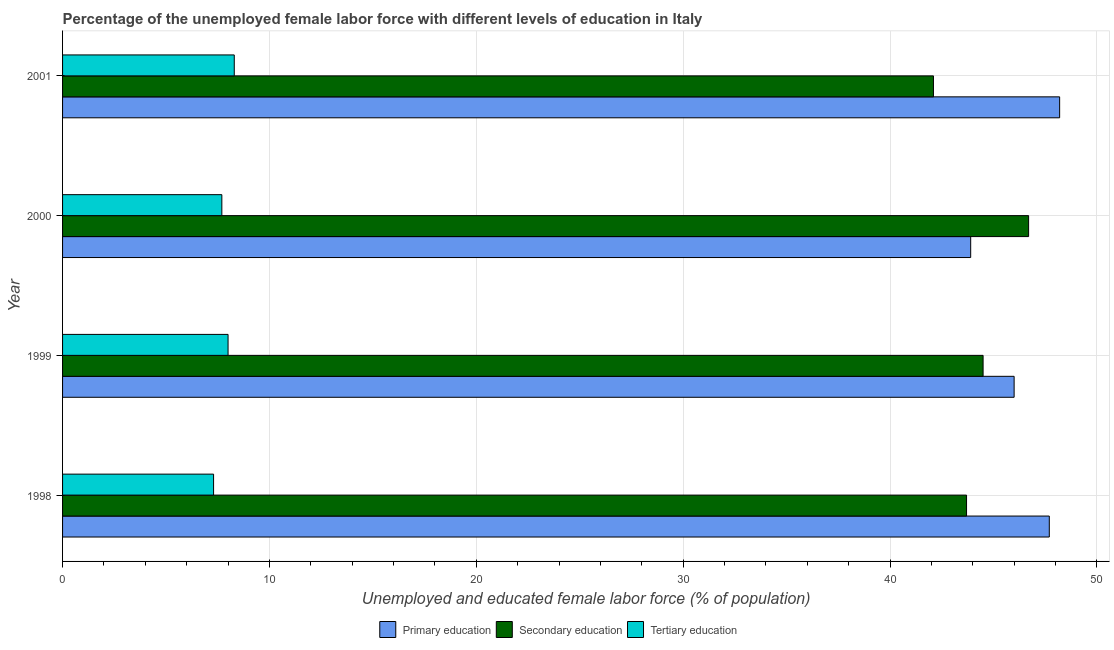How many groups of bars are there?
Give a very brief answer. 4. How many bars are there on the 4th tick from the top?
Your response must be concise. 3. How many bars are there on the 4th tick from the bottom?
Your answer should be compact. 3. What is the label of the 2nd group of bars from the top?
Your answer should be compact. 2000. In how many cases, is the number of bars for a given year not equal to the number of legend labels?
Your response must be concise. 0. What is the percentage of female labor force who received tertiary education in 2000?
Ensure brevity in your answer.  7.7. Across all years, what is the maximum percentage of female labor force who received primary education?
Give a very brief answer. 48.2. Across all years, what is the minimum percentage of female labor force who received tertiary education?
Provide a short and direct response. 7.3. In which year was the percentage of female labor force who received tertiary education maximum?
Your answer should be compact. 2001. In which year was the percentage of female labor force who received primary education minimum?
Offer a very short reply. 2000. What is the total percentage of female labor force who received secondary education in the graph?
Your response must be concise. 177. What is the difference between the percentage of female labor force who received secondary education in 1998 and the percentage of female labor force who received primary education in 2000?
Provide a short and direct response. -0.2. What is the average percentage of female labor force who received tertiary education per year?
Keep it short and to the point. 7.83. In the year 2001, what is the difference between the percentage of female labor force who received primary education and percentage of female labor force who received tertiary education?
Your answer should be compact. 39.9. In how many years, is the percentage of female labor force who received secondary education greater than 38 %?
Provide a succinct answer. 4. What is the ratio of the percentage of female labor force who received primary education in 1999 to that in 2000?
Your response must be concise. 1.05. What is the difference between the highest and the lowest percentage of female labor force who received primary education?
Provide a short and direct response. 4.3. Is the sum of the percentage of female labor force who received secondary education in 2000 and 2001 greater than the maximum percentage of female labor force who received primary education across all years?
Provide a succinct answer. Yes. What does the 1st bar from the top in 1999 represents?
Provide a succinct answer. Tertiary education. What does the 1st bar from the bottom in 1999 represents?
Offer a very short reply. Primary education. What is the difference between two consecutive major ticks on the X-axis?
Offer a very short reply. 10. Are the values on the major ticks of X-axis written in scientific E-notation?
Ensure brevity in your answer.  No. Does the graph contain any zero values?
Give a very brief answer. No. How are the legend labels stacked?
Your response must be concise. Horizontal. What is the title of the graph?
Offer a terse response. Percentage of the unemployed female labor force with different levels of education in Italy. What is the label or title of the X-axis?
Provide a short and direct response. Unemployed and educated female labor force (% of population). What is the label or title of the Y-axis?
Give a very brief answer. Year. What is the Unemployed and educated female labor force (% of population) of Primary education in 1998?
Keep it short and to the point. 47.7. What is the Unemployed and educated female labor force (% of population) of Secondary education in 1998?
Keep it short and to the point. 43.7. What is the Unemployed and educated female labor force (% of population) of Tertiary education in 1998?
Provide a short and direct response. 7.3. What is the Unemployed and educated female labor force (% of population) in Primary education in 1999?
Make the answer very short. 46. What is the Unemployed and educated female labor force (% of population) in Secondary education in 1999?
Keep it short and to the point. 44.5. What is the Unemployed and educated female labor force (% of population) in Tertiary education in 1999?
Offer a very short reply. 8. What is the Unemployed and educated female labor force (% of population) in Primary education in 2000?
Make the answer very short. 43.9. What is the Unemployed and educated female labor force (% of population) in Secondary education in 2000?
Offer a terse response. 46.7. What is the Unemployed and educated female labor force (% of population) in Tertiary education in 2000?
Your response must be concise. 7.7. What is the Unemployed and educated female labor force (% of population) of Primary education in 2001?
Provide a short and direct response. 48.2. What is the Unemployed and educated female labor force (% of population) of Secondary education in 2001?
Provide a short and direct response. 42.1. What is the Unemployed and educated female labor force (% of population) of Tertiary education in 2001?
Your answer should be very brief. 8.3. Across all years, what is the maximum Unemployed and educated female labor force (% of population) in Primary education?
Offer a terse response. 48.2. Across all years, what is the maximum Unemployed and educated female labor force (% of population) in Secondary education?
Your answer should be very brief. 46.7. Across all years, what is the maximum Unemployed and educated female labor force (% of population) of Tertiary education?
Offer a terse response. 8.3. Across all years, what is the minimum Unemployed and educated female labor force (% of population) of Primary education?
Offer a very short reply. 43.9. Across all years, what is the minimum Unemployed and educated female labor force (% of population) in Secondary education?
Provide a succinct answer. 42.1. Across all years, what is the minimum Unemployed and educated female labor force (% of population) in Tertiary education?
Provide a succinct answer. 7.3. What is the total Unemployed and educated female labor force (% of population) of Primary education in the graph?
Provide a short and direct response. 185.8. What is the total Unemployed and educated female labor force (% of population) in Secondary education in the graph?
Your answer should be very brief. 177. What is the total Unemployed and educated female labor force (% of population) in Tertiary education in the graph?
Make the answer very short. 31.3. What is the difference between the Unemployed and educated female labor force (% of population) in Primary education in 1998 and that in 1999?
Ensure brevity in your answer.  1.7. What is the difference between the Unemployed and educated female labor force (% of population) of Secondary education in 1998 and that in 1999?
Offer a very short reply. -0.8. What is the difference between the Unemployed and educated female labor force (% of population) of Tertiary education in 1998 and that in 1999?
Ensure brevity in your answer.  -0.7. What is the difference between the Unemployed and educated female labor force (% of population) of Secondary education in 1998 and that in 2000?
Ensure brevity in your answer.  -3. What is the difference between the Unemployed and educated female labor force (% of population) of Primary education in 1998 and that in 2001?
Make the answer very short. -0.5. What is the difference between the Unemployed and educated female labor force (% of population) in Secondary education in 1999 and that in 2000?
Offer a very short reply. -2.2. What is the difference between the Unemployed and educated female labor force (% of population) in Tertiary education in 2000 and that in 2001?
Your answer should be very brief. -0.6. What is the difference between the Unemployed and educated female labor force (% of population) of Primary education in 1998 and the Unemployed and educated female labor force (% of population) of Tertiary education in 1999?
Keep it short and to the point. 39.7. What is the difference between the Unemployed and educated female labor force (% of population) in Secondary education in 1998 and the Unemployed and educated female labor force (% of population) in Tertiary education in 1999?
Give a very brief answer. 35.7. What is the difference between the Unemployed and educated female labor force (% of population) of Primary education in 1998 and the Unemployed and educated female labor force (% of population) of Tertiary education in 2000?
Your answer should be very brief. 40. What is the difference between the Unemployed and educated female labor force (% of population) in Secondary education in 1998 and the Unemployed and educated female labor force (% of population) in Tertiary education in 2000?
Give a very brief answer. 36. What is the difference between the Unemployed and educated female labor force (% of population) of Primary education in 1998 and the Unemployed and educated female labor force (% of population) of Tertiary education in 2001?
Offer a terse response. 39.4. What is the difference between the Unemployed and educated female labor force (% of population) in Secondary education in 1998 and the Unemployed and educated female labor force (% of population) in Tertiary education in 2001?
Provide a succinct answer. 35.4. What is the difference between the Unemployed and educated female labor force (% of population) of Primary education in 1999 and the Unemployed and educated female labor force (% of population) of Tertiary education in 2000?
Offer a very short reply. 38.3. What is the difference between the Unemployed and educated female labor force (% of population) of Secondary education in 1999 and the Unemployed and educated female labor force (% of population) of Tertiary education in 2000?
Your answer should be very brief. 36.8. What is the difference between the Unemployed and educated female labor force (% of population) of Primary education in 1999 and the Unemployed and educated female labor force (% of population) of Tertiary education in 2001?
Keep it short and to the point. 37.7. What is the difference between the Unemployed and educated female labor force (% of population) in Secondary education in 1999 and the Unemployed and educated female labor force (% of population) in Tertiary education in 2001?
Make the answer very short. 36.2. What is the difference between the Unemployed and educated female labor force (% of population) in Primary education in 2000 and the Unemployed and educated female labor force (% of population) in Secondary education in 2001?
Offer a very short reply. 1.8. What is the difference between the Unemployed and educated female labor force (% of population) of Primary education in 2000 and the Unemployed and educated female labor force (% of population) of Tertiary education in 2001?
Your response must be concise. 35.6. What is the difference between the Unemployed and educated female labor force (% of population) in Secondary education in 2000 and the Unemployed and educated female labor force (% of population) in Tertiary education in 2001?
Offer a terse response. 38.4. What is the average Unemployed and educated female labor force (% of population) of Primary education per year?
Make the answer very short. 46.45. What is the average Unemployed and educated female labor force (% of population) of Secondary education per year?
Give a very brief answer. 44.25. What is the average Unemployed and educated female labor force (% of population) of Tertiary education per year?
Your answer should be very brief. 7.83. In the year 1998, what is the difference between the Unemployed and educated female labor force (% of population) of Primary education and Unemployed and educated female labor force (% of population) of Secondary education?
Keep it short and to the point. 4. In the year 1998, what is the difference between the Unemployed and educated female labor force (% of population) of Primary education and Unemployed and educated female labor force (% of population) of Tertiary education?
Give a very brief answer. 40.4. In the year 1998, what is the difference between the Unemployed and educated female labor force (% of population) in Secondary education and Unemployed and educated female labor force (% of population) in Tertiary education?
Keep it short and to the point. 36.4. In the year 1999, what is the difference between the Unemployed and educated female labor force (% of population) of Primary education and Unemployed and educated female labor force (% of population) of Secondary education?
Your answer should be very brief. 1.5. In the year 1999, what is the difference between the Unemployed and educated female labor force (% of population) in Secondary education and Unemployed and educated female labor force (% of population) in Tertiary education?
Provide a succinct answer. 36.5. In the year 2000, what is the difference between the Unemployed and educated female labor force (% of population) of Primary education and Unemployed and educated female labor force (% of population) of Tertiary education?
Give a very brief answer. 36.2. In the year 2001, what is the difference between the Unemployed and educated female labor force (% of population) of Primary education and Unemployed and educated female labor force (% of population) of Secondary education?
Make the answer very short. 6.1. In the year 2001, what is the difference between the Unemployed and educated female labor force (% of population) of Primary education and Unemployed and educated female labor force (% of population) of Tertiary education?
Provide a short and direct response. 39.9. In the year 2001, what is the difference between the Unemployed and educated female labor force (% of population) in Secondary education and Unemployed and educated female labor force (% of population) in Tertiary education?
Offer a terse response. 33.8. What is the ratio of the Unemployed and educated female labor force (% of population) in Primary education in 1998 to that in 1999?
Your answer should be compact. 1.04. What is the ratio of the Unemployed and educated female labor force (% of population) in Tertiary education in 1998 to that in 1999?
Give a very brief answer. 0.91. What is the ratio of the Unemployed and educated female labor force (% of population) in Primary education in 1998 to that in 2000?
Keep it short and to the point. 1.09. What is the ratio of the Unemployed and educated female labor force (% of population) of Secondary education in 1998 to that in 2000?
Keep it short and to the point. 0.94. What is the ratio of the Unemployed and educated female labor force (% of population) in Tertiary education in 1998 to that in 2000?
Make the answer very short. 0.95. What is the ratio of the Unemployed and educated female labor force (% of population) in Primary education in 1998 to that in 2001?
Keep it short and to the point. 0.99. What is the ratio of the Unemployed and educated female labor force (% of population) in Secondary education in 1998 to that in 2001?
Your answer should be very brief. 1.04. What is the ratio of the Unemployed and educated female labor force (% of population) in Tertiary education in 1998 to that in 2001?
Your response must be concise. 0.88. What is the ratio of the Unemployed and educated female labor force (% of population) of Primary education in 1999 to that in 2000?
Provide a succinct answer. 1.05. What is the ratio of the Unemployed and educated female labor force (% of population) of Secondary education in 1999 to that in 2000?
Your response must be concise. 0.95. What is the ratio of the Unemployed and educated female labor force (% of population) in Tertiary education in 1999 to that in 2000?
Ensure brevity in your answer.  1.04. What is the ratio of the Unemployed and educated female labor force (% of population) of Primary education in 1999 to that in 2001?
Provide a short and direct response. 0.95. What is the ratio of the Unemployed and educated female labor force (% of population) in Secondary education in 1999 to that in 2001?
Your answer should be compact. 1.06. What is the ratio of the Unemployed and educated female labor force (% of population) in Tertiary education in 1999 to that in 2001?
Ensure brevity in your answer.  0.96. What is the ratio of the Unemployed and educated female labor force (% of population) of Primary education in 2000 to that in 2001?
Give a very brief answer. 0.91. What is the ratio of the Unemployed and educated female labor force (% of population) in Secondary education in 2000 to that in 2001?
Offer a terse response. 1.11. What is the ratio of the Unemployed and educated female labor force (% of population) of Tertiary education in 2000 to that in 2001?
Your answer should be compact. 0.93. What is the difference between the highest and the lowest Unemployed and educated female labor force (% of population) of Primary education?
Your answer should be very brief. 4.3. What is the difference between the highest and the lowest Unemployed and educated female labor force (% of population) of Secondary education?
Make the answer very short. 4.6. 